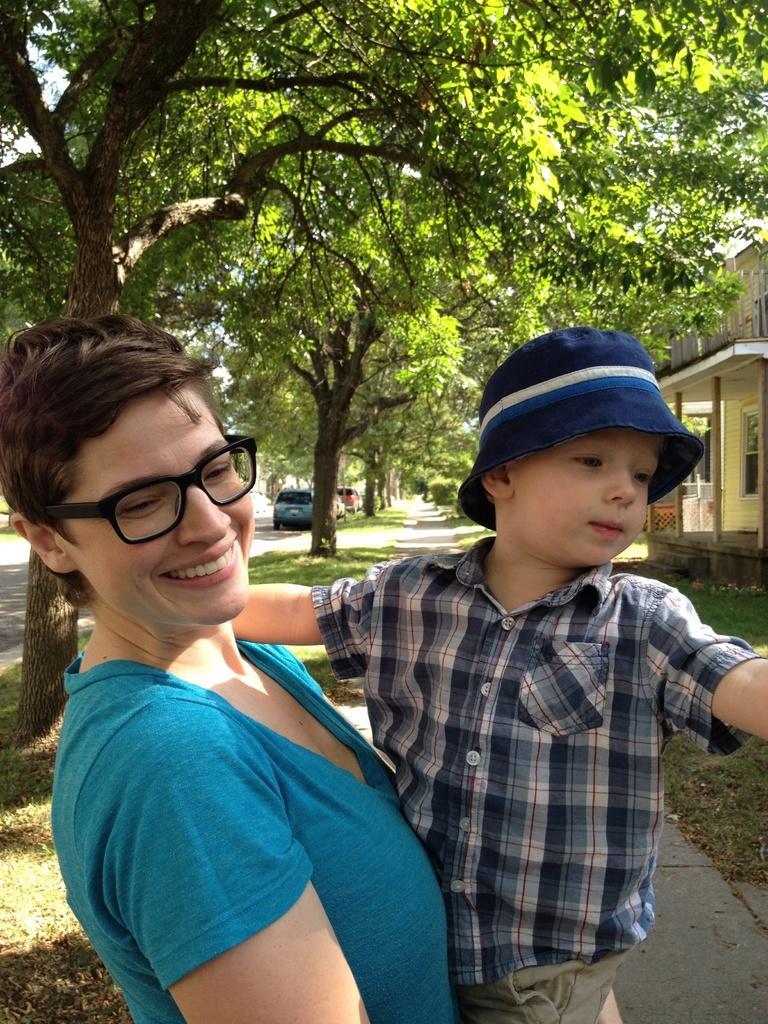Please provide a concise description of this image. In the image there is a woman in sea green t-shirt holding a boy, this is clicked on a street, on the left side there are trees on garden all over the image and on the right side there is a building, on the left there are few cars going on the road. 